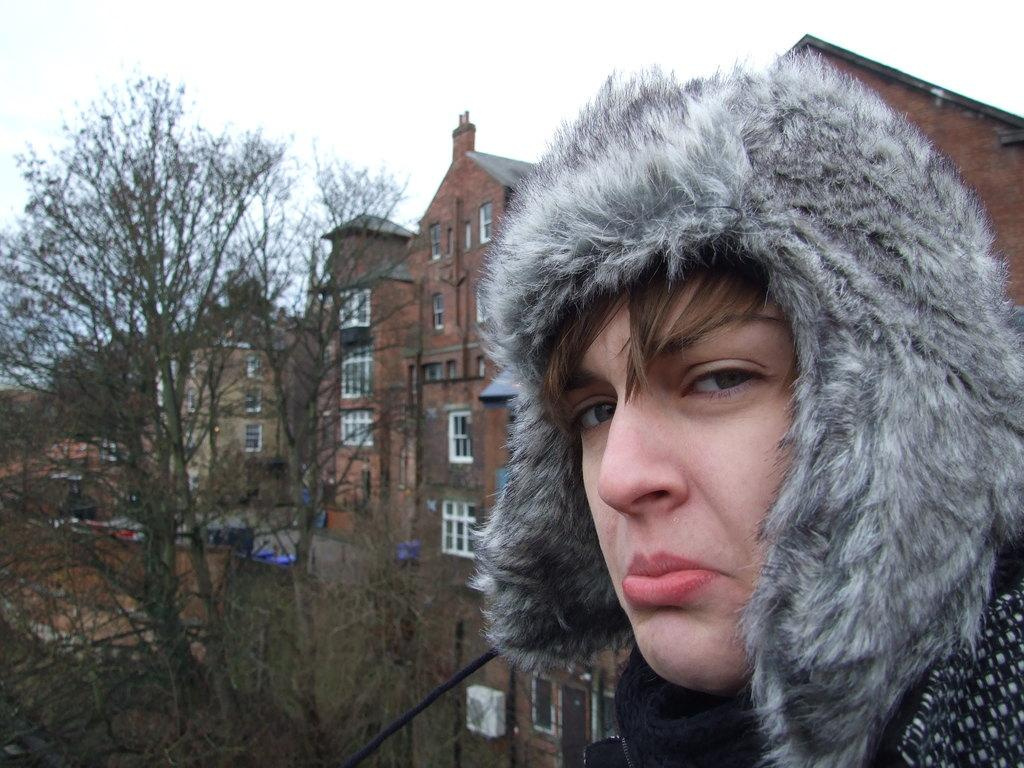Who or what is the main subject of the image? There is a person in the image. What is the person wearing in the image? The person is wearing a coat. What can be seen in the background of the image? There are trees and buildings in the background of the image. What is visible at the top of the image? The sky is visible at the top of the image. What type of cable is being used by the person in the image? There is no cable visible in the image; the person is wearing a coat and standing in front of trees and buildings. What historical event is being depicted in the image? The image does not depict any specific historical event; it simply shows a person wearing a coat with trees, buildings, and the sky visible in the background. 